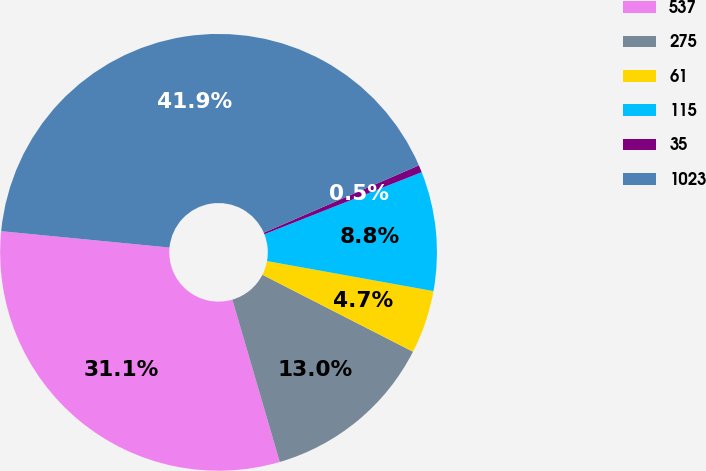<chart> <loc_0><loc_0><loc_500><loc_500><pie_chart><fcel>537<fcel>275<fcel>61<fcel>115<fcel>35<fcel>1023<nl><fcel>31.07%<fcel>12.96%<fcel>4.68%<fcel>8.82%<fcel>0.54%<fcel>41.94%<nl></chart> 